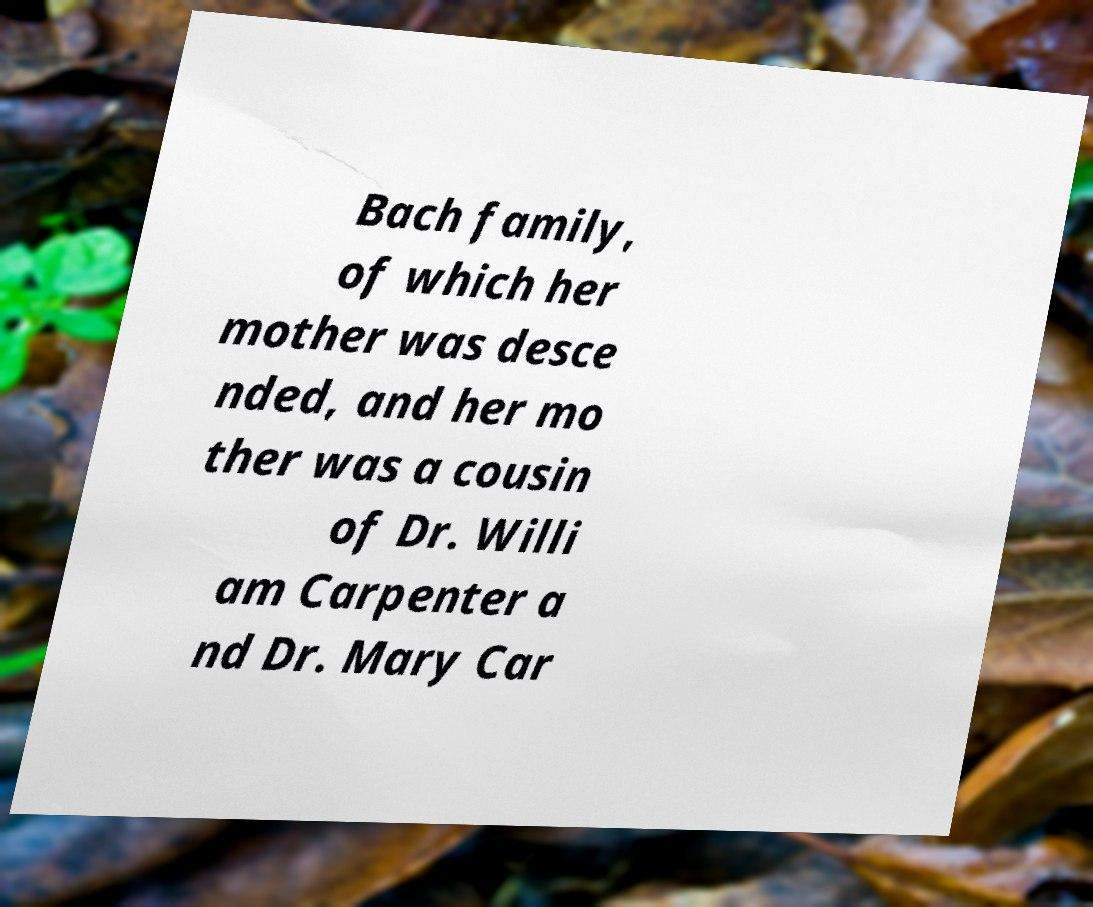Can you read and provide the text displayed in the image?This photo seems to have some interesting text. Can you extract and type it out for me? Bach family, of which her mother was desce nded, and her mo ther was a cousin of Dr. Willi am Carpenter a nd Dr. Mary Car 